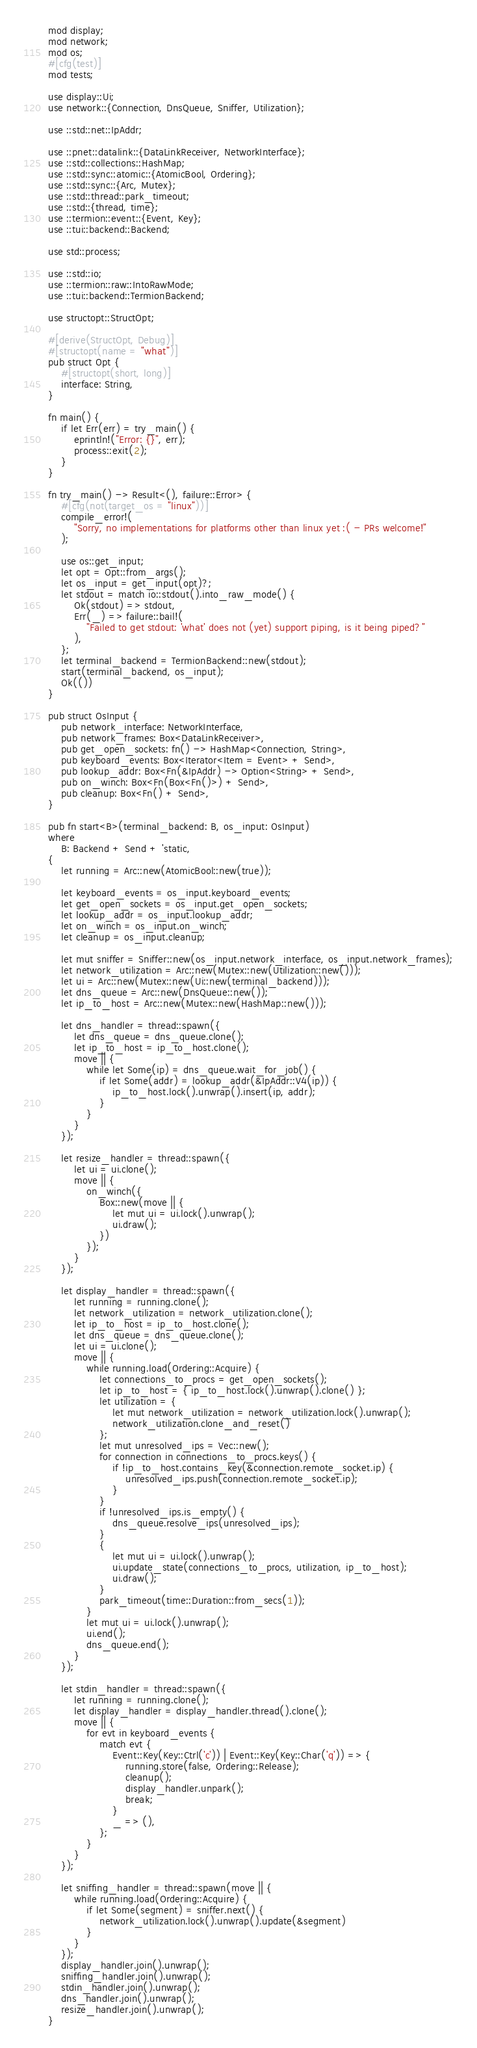Convert code to text. <code><loc_0><loc_0><loc_500><loc_500><_Rust_>mod display;
mod network;
mod os;
#[cfg(test)]
mod tests;

use display::Ui;
use network::{Connection, DnsQueue, Sniffer, Utilization};

use ::std::net::IpAddr;

use ::pnet::datalink::{DataLinkReceiver, NetworkInterface};
use ::std::collections::HashMap;
use ::std::sync::atomic::{AtomicBool, Ordering};
use ::std::sync::{Arc, Mutex};
use ::std::thread::park_timeout;
use ::std::{thread, time};
use ::termion::event::{Event, Key};
use ::tui::backend::Backend;

use std::process;

use ::std::io;
use ::termion::raw::IntoRawMode;
use ::tui::backend::TermionBackend;

use structopt::StructOpt;

#[derive(StructOpt, Debug)]
#[structopt(name = "what")]
pub struct Opt {
    #[structopt(short, long)]
    interface: String,
}

fn main() {
    if let Err(err) = try_main() {
        eprintln!("Error: {}", err);
        process::exit(2);
    }
}

fn try_main() -> Result<(), failure::Error> {
    #[cfg(not(target_os = "linux"))]
    compile_error!(
        "Sorry, no implementations for platforms other than linux yet :( - PRs welcome!"
    );

    use os::get_input;
    let opt = Opt::from_args();
    let os_input = get_input(opt)?;
    let stdout = match io::stdout().into_raw_mode() {
        Ok(stdout) => stdout,
        Err(_) => failure::bail!(
            "Failed to get stdout: 'what' does not (yet) support piping, is it being piped?"
        ),
    };
    let terminal_backend = TermionBackend::new(stdout);
    start(terminal_backend, os_input);
    Ok(())
}

pub struct OsInput {
    pub network_interface: NetworkInterface,
    pub network_frames: Box<DataLinkReceiver>,
    pub get_open_sockets: fn() -> HashMap<Connection, String>,
    pub keyboard_events: Box<Iterator<Item = Event> + Send>,
    pub lookup_addr: Box<Fn(&IpAddr) -> Option<String> + Send>,
    pub on_winch: Box<Fn(Box<Fn()>) + Send>,
    pub cleanup: Box<Fn() + Send>,
}

pub fn start<B>(terminal_backend: B, os_input: OsInput)
where
    B: Backend + Send + 'static,
{
    let running = Arc::new(AtomicBool::new(true));

    let keyboard_events = os_input.keyboard_events;
    let get_open_sockets = os_input.get_open_sockets;
    let lookup_addr = os_input.lookup_addr;
    let on_winch = os_input.on_winch;
    let cleanup = os_input.cleanup;

    let mut sniffer = Sniffer::new(os_input.network_interface, os_input.network_frames);
    let network_utilization = Arc::new(Mutex::new(Utilization::new()));
    let ui = Arc::new(Mutex::new(Ui::new(terminal_backend)));
    let dns_queue = Arc::new(DnsQueue::new());
    let ip_to_host = Arc::new(Mutex::new(HashMap::new()));

    let dns_handler = thread::spawn({
        let dns_queue = dns_queue.clone();
        let ip_to_host = ip_to_host.clone();
        move || {
            while let Some(ip) = dns_queue.wait_for_job() {
                if let Some(addr) = lookup_addr(&IpAddr::V4(ip)) {
                    ip_to_host.lock().unwrap().insert(ip, addr);
                }
            }
        }
    });

    let resize_handler = thread::spawn({
        let ui = ui.clone();
        move || {
            on_winch({
                Box::new(move || {
                    let mut ui = ui.lock().unwrap();
                    ui.draw();
                })
            });
        }
    });

    let display_handler = thread::spawn({
        let running = running.clone();
        let network_utilization = network_utilization.clone();
        let ip_to_host = ip_to_host.clone();
        let dns_queue = dns_queue.clone();
        let ui = ui.clone();
        move || {
            while running.load(Ordering::Acquire) {
                let connections_to_procs = get_open_sockets();
                let ip_to_host = { ip_to_host.lock().unwrap().clone() };
                let utilization = {
                    let mut network_utilization = network_utilization.lock().unwrap();
                    network_utilization.clone_and_reset()
                };
                let mut unresolved_ips = Vec::new();
                for connection in connections_to_procs.keys() {
                    if !ip_to_host.contains_key(&connection.remote_socket.ip) {
                        unresolved_ips.push(connection.remote_socket.ip);
                    }
                }
                if !unresolved_ips.is_empty() {
                    dns_queue.resolve_ips(unresolved_ips);
                }
                {
                    let mut ui = ui.lock().unwrap();
                    ui.update_state(connections_to_procs, utilization, ip_to_host);
                    ui.draw();
                }
                park_timeout(time::Duration::from_secs(1));
            }
            let mut ui = ui.lock().unwrap();
            ui.end();
            dns_queue.end();
        }
    });

    let stdin_handler = thread::spawn({
        let running = running.clone();
        let display_handler = display_handler.thread().clone();
        move || {
            for evt in keyboard_events {
                match evt {
                    Event::Key(Key::Ctrl('c')) | Event::Key(Key::Char('q')) => {
                        running.store(false, Ordering::Release);
                        cleanup();
                        display_handler.unpark();
                        break;
                    }
                    _ => (),
                };
            }
        }
    });

    let sniffing_handler = thread::spawn(move || {
        while running.load(Ordering::Acquire) {
            if let Some(segment) = sniffer.next() {
                network_utilization.lock().unwrap().update(&segment)
            }
        }
    });
    display_handler.join().unwrap();
    sniffing_handler.join().unwrap();
    stdin_handler.join().unwrap();
    dns_handler.join().unwrap();
    resize_handler.join().unwrap();
}
</code> 